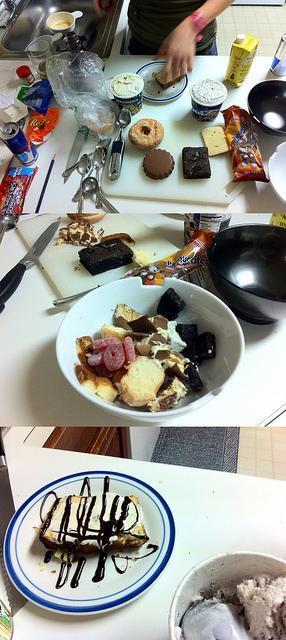How many bowls are in the photo?
Give a very brief answer. 3. How many dining tables are there?
Give a very brief answer. 3. How many orange cups are on the table?
Give a very brief answer. 0. 